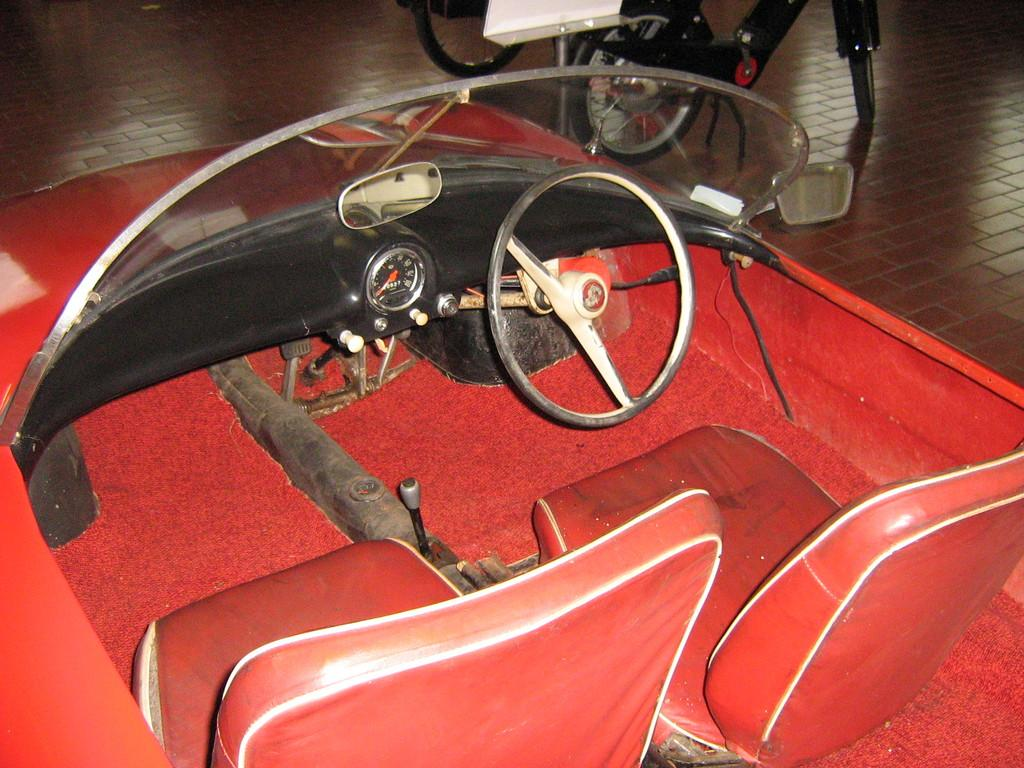What color is the vehicle in the image? The vehicle in the image is red. What can be found inside the vehicle? The vehicle has red color seats. What safety features are present in the vehicle? The vehicle has mirrors. How does the driver control the vehicle? The vehicle has a steering wheel. How can the driver monitor the speed of the vehicle? The vehicle has a speedometer. What can be seen in the background of the image? There are other vehicles visible in the background of the image. Can you see any kites flying in the image? There are no kites visible in the image. What is the sun's position in the image? The sun is not visible in the image. 